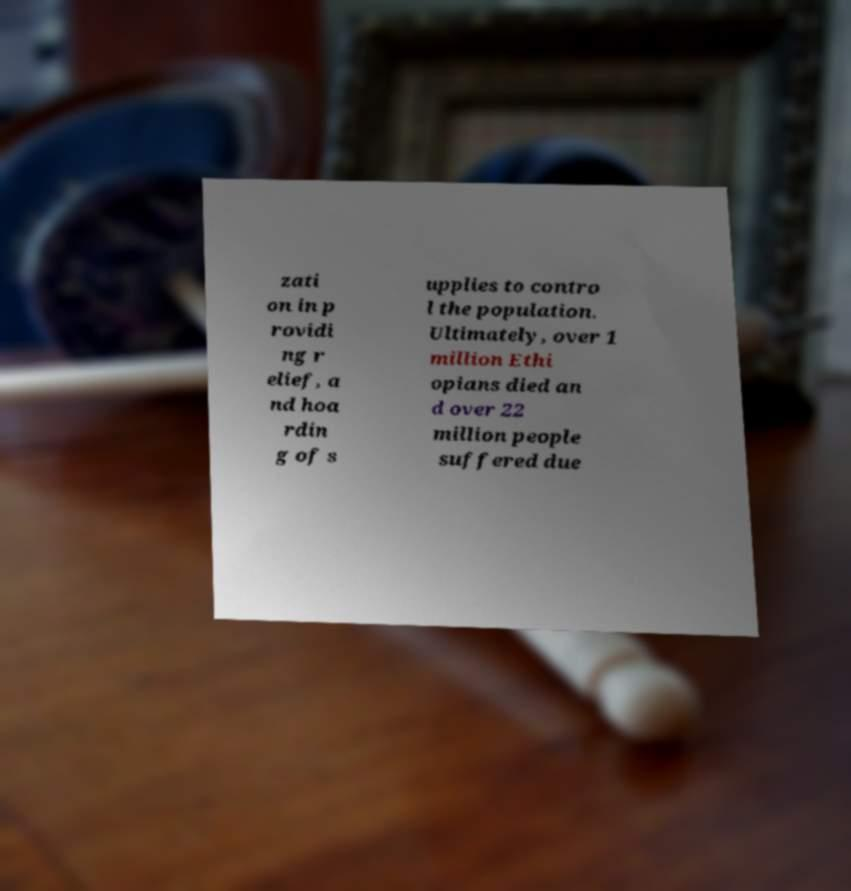I need the written content from this picture converted into text. Can you do that? zati on in p rovidi ng r elief, a nd hoa rdin g of s upplies to contro l the population. Ultimately, over 1 million Ethi opians died an d over 22 million people suffered due 